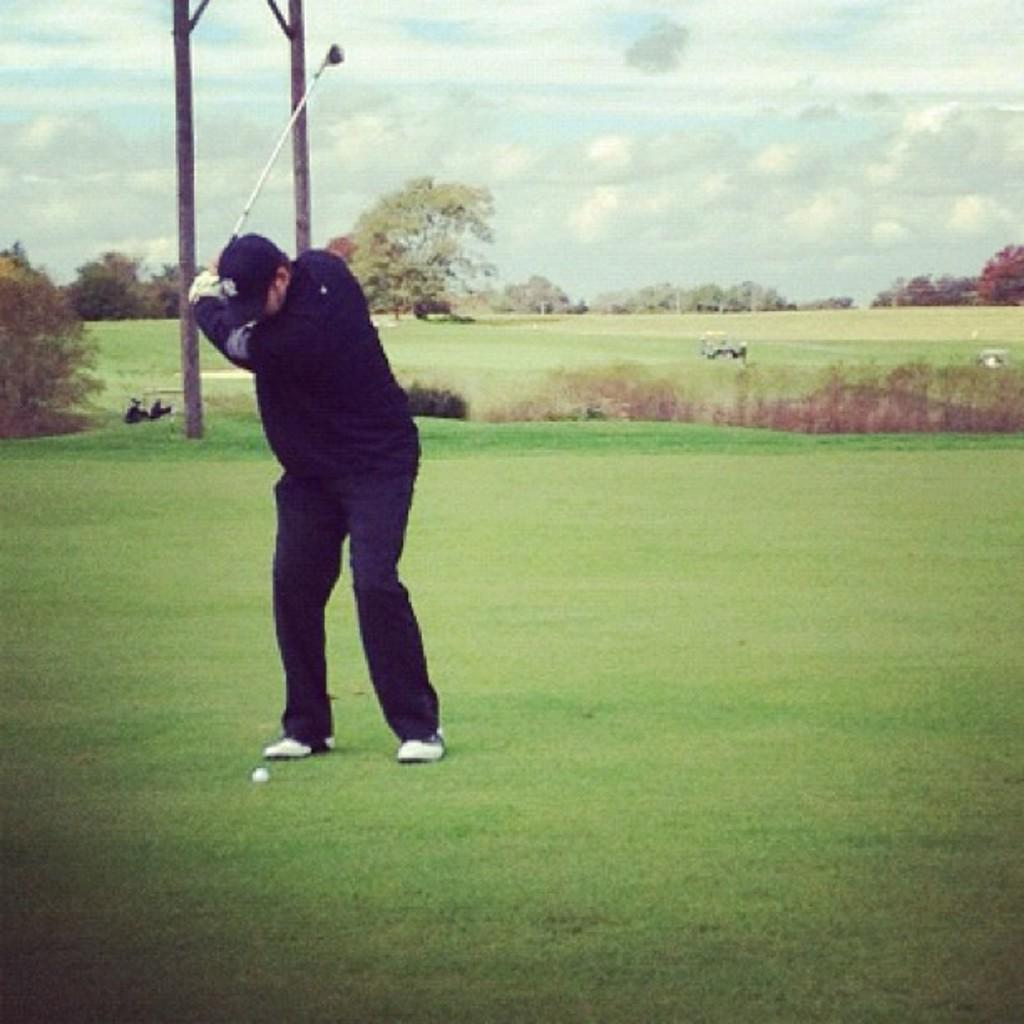What is the person in the image wearing? The person is wearing a black dress and cap. What is the person holding in the image? The person is holding a golf bat. Where is the person standing in the image? The person is standing on the ground. What can be seen in the background of the image? There are poles, trees, and the sky visible in the background of the image. What type of fang can be seen in the image? There is no fang present in the image. What day of the week is it in the image? The day of the week is not mentioned or visible in the image. 